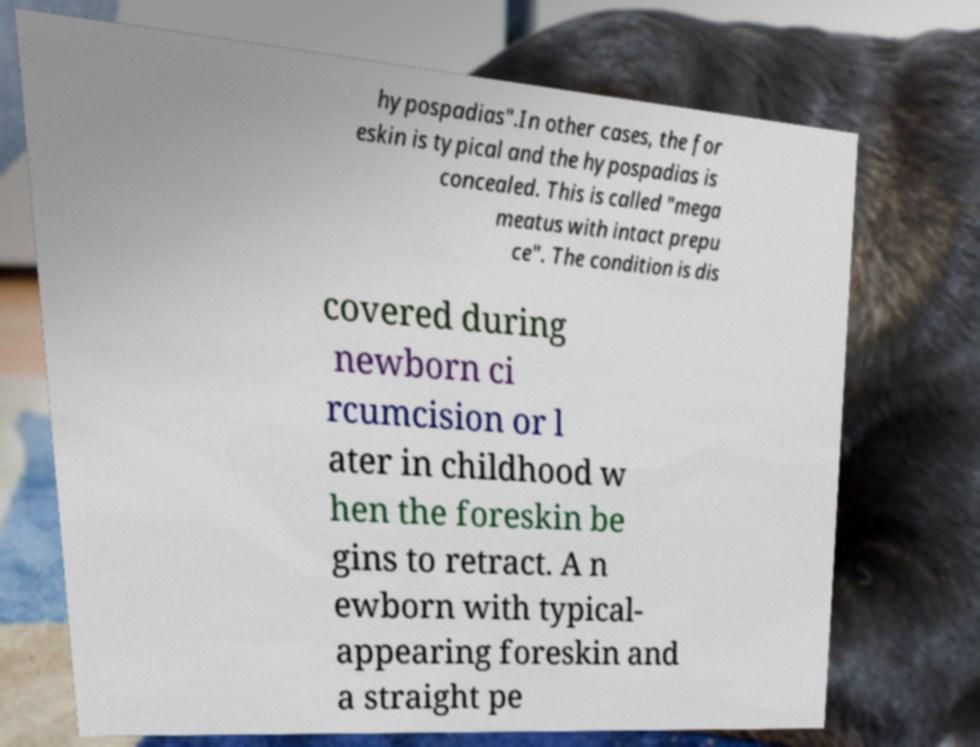Please read and relay the text visible in this image. What does it say? hypospadias".In other cases, the for eskin is typical and the hypospadias is concealed. This is called "mega meatus with intact prepu ce". The condition is dis covered during newborn ci rcumcision or l ater in childhood w hen the foreskin be gins to retract. A n ewborn with typical- appearing foreskin and a straight pe 